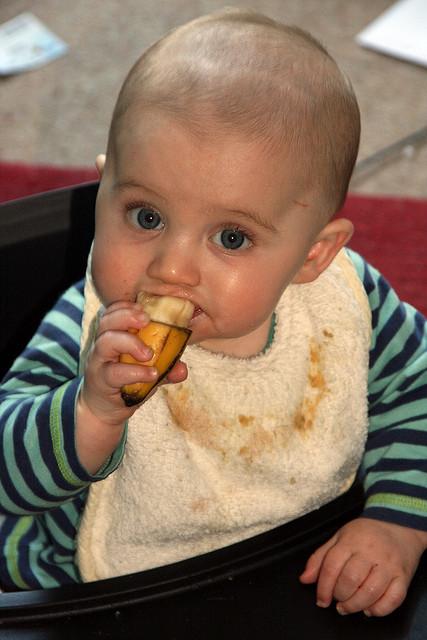What is the baby eating?
Give a very brief answer. Banana. Will this person need to brush his or her teeth?
Short answer required. Yes. What is the design of the baby's shirt?
Write a very short answer. Striped. 